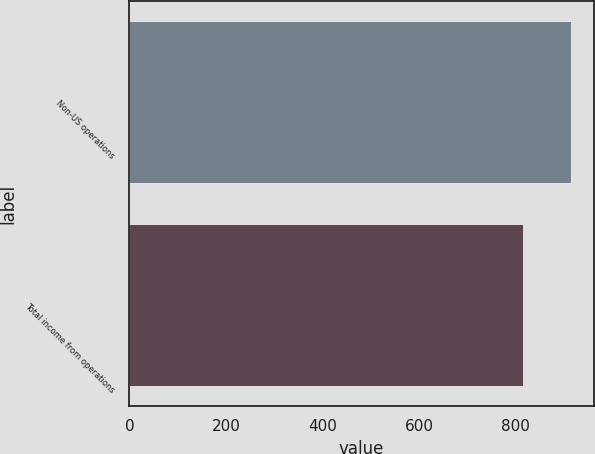Convert chart to OTSL. <chart><loc_0><loc_0><loc_500><loc_500><bar_chart><fcel>Non-US operations<fcel>Total income from operations<nl><fcel>915<fcel>815<nl></chart> 